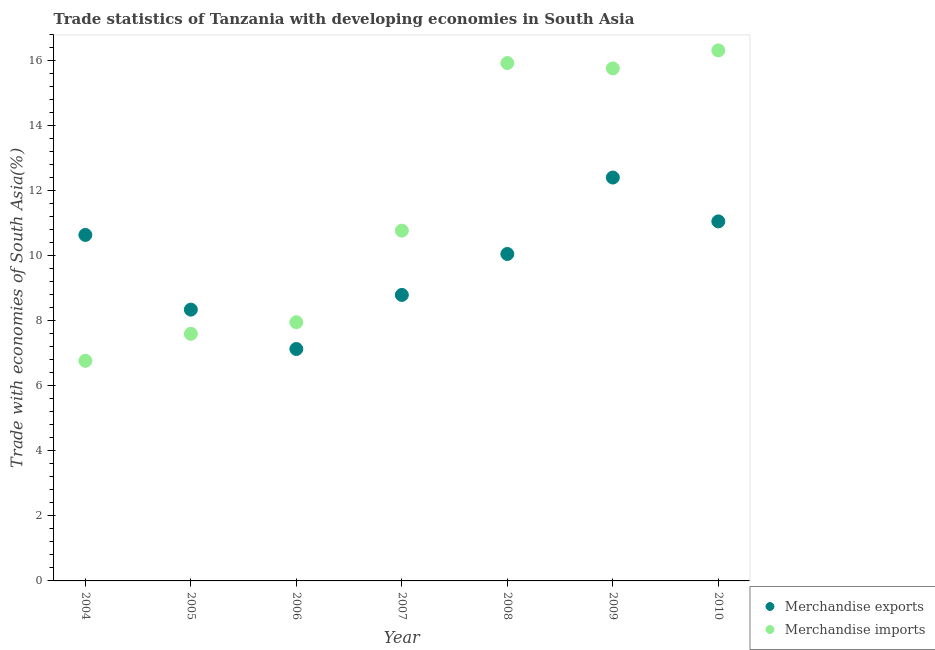What is the merchandise imports in 2004?
Ensure brevity in your answer.  6.77. Across all years, what is the maximum merchandise exports?
Offer a very short reply. 12.41. Across all years, what is the minimum merchandise imports?
Ensure brevity in your answer.  6.77. What is the total merchandise exports in the graph?
Give a very brief answer. 68.47. What is the difference between the merchandise imports in 2005 and that in 2006?
Give a very brief answer. -0.36. What is the difference between the merchandise imports in 2007 and the merchandise exports in 2009?
Your answer should be very brief. -1.63. What is the average merchandise exports per year?
Your answer should be very brief. 9.78. In the year 2008, what is the difference between the merchandise imports and merchandise exports?
Keep it short and to the point. 5.87. What is the ratio of the merchandise imports in 2004 to that in 2008?
Keep it short and to the point. 0.43. Is the merchandise exports in 2004 less than that in 2009?
Make the answer very short. Yes. What is the difference between the highest and the second highest merchandise imports?
Offer a terse response. 0.39. What is the difference between the highest and the lowest merchandise imports?
Offer a terse response. 9.55. In how many years, is the merchandise exports greater than the average merchandise exports taken over all years?
Your answer should be compact. 4. Does the merchandise exports monotonically increase over the years?
Your answer should be very brief. No. Is the merchandise exports strictly greater than the merchandise imports over the years?
Offer a terse response. No. Is the merchandise imports strictly less than the merchandise exports over the years?
Your answer should be compact. No. How many years are there in the graph?
Make the answer very short. 7. What is the difference between two consecutive major ticks on the Y-axis?
Provide a short and direct response. 2. Does the graph contain any zero values?
Your answer should be very brief. No. How many legend labels are there?
Make the answer very short. 2. How are the legend labels stacked?
Your answer should be very brief. Vertical. What is the title of the graph?
Ensure brevity in your answer.  Trade statistics of Tanzania with developing economies in South Asia. Does "ODA received" appear as one of the legend labels in the graph?
Your answer should be very brief. No. What is the label or title of the Y-axis?
Your answer should be very brief. Trade with economies of South Asia(%). What is the Trade with economies of South Asia(%) in Merchandise exports in 2004?
Offer a very short reply. 10.65. What is the Trade with economies of South Asia(%) of Merchandise imports in 2004?
Your answer should be compact. 6.77. What is the Trade with economies of South Asia(%) of Merchandise exports in 2005?
Give a very brief answer. 8.35. What is the Trade with economies of South Asia(%) of Merchandise imports in 2005?
Your answer should be very brief. 7.6. What is the Trade with economies of South Asia(%) in Merchandise exports in 2006?
Provide a short and direct response. 7.14. What is the Trade with economies of South Asia(%) in Merchandise imports in 2006?
Provide a short and direct response. 7.96. What is the Trade with economies of South Asia(%) of Merchandise exports in 2007?
Provide a short and direct response. 8.8. What is the Trade with economies of South Asia(%) of Merchandise imports in 2007?
Provide a short and direct response. 10.78. What is the Trade with economies of South Asia(%) in Merchandise exports in 2008?
Provide a succinct answer. 10.06. What is the Trade with economies of South Asia(%) of Merchandise imports in 2008?
Ensure brevity in your answer.  15.94. What is the Trade with economies of South Asia(%) in Merchandise exports in 2009?
Your response must be concise. 12.41. What is the Trade with economies of South Asia(%) of Merchandise imports in 2009?
Provide a short and direct response. 15.77. What is the Trade with economies of South Asia(%) of Merchandise exports in 2010?
Provide a succinct answer. 11.06. What is the Trade with economies of South Asia(%) of Merchandise imports in 2010?
Make the answer very short. 16.32. Across all years, what is the maximum Trade with economies of South Asia(%) of Merchandise exports?
Make the answer very short. 12.41. Across all years, what is the maximum Trade with economies of South Asia(%) in Merchandise imports?
Your answer should be compact. 16.32. Across all years, what is the minimum Trade with economies of South Asia(%) of Merchandise exports?
Your response must be concise. 7.14. Across all years, what is the minimum Trade with economies of South Asia(%) in Merchandise imports?
Provide a succinct answer. 6.77. What is the total Trade with economies of South Asia(%) in Merchandise exports in the graph?
Provide a succinct answer. 68.47. What is the total Trade with economies of South Asia(%) in Merchandise imports in the graph?
Ensure brevity in your answer.  81.15. What is the difference between the Trade with economies of South Asia(%) of Merchandise exports in 2004 and that in 2005?
Provide a succinct answer. 2.3. What is the difference between the Trade with economies of South Asia(%) of Merchandise imports in 2004 and that in 2005?
Offer a terse response. -0.83. What is the difference between the Trade with economies of South Asia(%) in Merchandise exports in 2004 and that in 2006?
Offer a very short reply. 3.51. What is the difference between the Trade with economies of South Asia(%) in Merchandise imports in 2004 and that in 2006?
Make the answer very short. -1.19. What is the difference between the Trade with economies of South Asia(%) of Merchandise exports in 2004 and that in 2007?
Keep it short and to the point. 1.85. What is the difference between the Trade with economies of South Asia(%) of Merchandise imports in 2004 and that in 2007?
Give a very brief answer. -4.01. What is the difference between the Trade with economies of South Asia(%) of Merchandise exports in 2004 and that in 2008?
Offer a terse response. 0.59. What is the difference between the Trade with economies of South Asia(%) of Merchandise imports in 2004 and that in 2008?
Offer a terse response. -9.16. What is the difference between the Trade with economies of South Asia(%) of Merchandise exports in 2004 and that in 2009?
Your response must be concise. -1.77. What is the difference between the Trade with economies of South Asia(%) in Merchandise imports in 2004 and that in 2009?
Make the answer very short. -9. What is the difference between the Trade with economies of South Asia(%) in Merchandise exports in 2004 and that in 2010?
Provide a short and direct response. -0.42. What is the difference between the Trade with economies of South Asia(%) in Merchandise imports in 2004 and that in 2010?
Offer a terse response. -9.55. What is the difference between the Trade with economies of South Asia(%) in Merchandise exports in 2005 and that in 2006?
Make the answer very short. 1.21. What is the difference between the Trade with economies of South Asia(%) of Merchandise imports in 2005 and that in 2006?
Your response must be concise. -0.36. What is the difference between the Trade with economies of South Asia(%) in Merchandise exports in 2005 and that in 2007?
Give a very brief answer. -0.45. What is the difference between the Trade with economies of South Asia(%) in Merchandise imports in 2005 and that in 2007?
Your answer should be very brief. -3.17. What is the difference between the Trade with economies of South Asia(%) in Merchandise exports in 2005 and that in 2008?
Provide a succinct answer. -1.71. What is the difference between the Trade with economies of South Asia(%) of Merchandise imports in 2005 and that in 2008?
Your answer should be very brief. -8.33. What is the difference between the Trade with economies of South Asia(%) of Merchandise exports in 2005 and that in 2009?
Provide a short and direct response. -4.06. What is the difference between the Trade with economies of South Asia(%) in Merchandise imports in 2005 and that in 2009?
Give a very brief answer. -8.17. What is the difference between the Trade with economies of South Asia(%) in Merchandise exports in 2005 and that in 2010?
Give a very brief answer. -2.71. What is the difference between the Trade with economies of South Asia(%) of Merchandise imports in 2005 and that in 2010?
Offer a very short reply. -8.72. What is the difference between the Trade with economies of South Asia(%) of Merchandise exports in 2006 and that in 2007?
Provide a short and direct response. -1.66. What is the difference between the Trade with economies of South Asia(%) of Merchandise imports in 2006 and that in 2007?
Offer a terse response. -2.82. What is the difference between the Trade with economies of South Asia(%) in Merchandise exports in 2006 and that in 2008?
Ensure brevity in your answer.  -2.92. What is the difference between the Trade with economies of South Asia(%) in Merchandise imports in 2006 and that in 2008?
Keep it short and to the point. -7.97. What is the difference between the Trade with economies of South Asia(%) of Merchandise exports in 2006 and that in 2009?
Provide a succinct answer. -5.28. What is the difference between the Trade with economies of South Asia(%) in Merchandise imports in 2006 and that in 2009?
Keep it short and to the point. -7.81. What is the difference between the Trade with economies of South Asia(%) of Merchandise exports in 2006 and that in 2010?
Your answer should be very brief. -3.93. What is the difference between the Trade with economies of South Asia(%) in Merchandise imports in 2006 and that in 2010?
Ensure brevity in your answer.  -8.36. What is the difference between the Trade with economies of South Asia(%) of Merchandise exports in 2007 and that in 2008?
Give a very brief answer. -1.26. What is the difference between the Trade with economies of South Asia(%) in Merchandise imports in 2007 and that in 2008?
Ensure brevity in your answer.  -5.16. What is the difference between the Trade with economies of South Asia(%) in Merchandise exports in 2007 and that in 2009?
Ensure brevity in your answer.  -3.61. What is the difference between the Trade with economies of South Asia(%) in Merchandise imports in 2007 and that in 2009?
Offer a very short reply. -4.99. What is the difference between the Trade with economies of South Asia(%) in Merchandise exports in 2007 and that in 2010?
Provide a short and direct response. -2.26. What is the difference between the Trade with economies of South Asia(%) of Merchandise imports in 2007 and that in 2010?
Ensure brevity in your answer.  -5.55. What is the difference between the Trade with economies of South Asia(%) of Merchandise exports in 2008 and that in 2009?
Offer a very short reply. -2.35. What is the difference between the Trade with economies of South Asia(%) of Merchandise imports in 2008 and that in 2009?
Provide a short and direct response. 0.17. What is the difference between the Trade with economies of South Asia(%) in Merchandise exports in 2008 and that in 2010?
Make the answer very short. -1. What is the difference between the Trade with economies of South Asia(%) of Merchandise imports in 2008 and that in 2010?
Offer a terse response. -0.39. What is the difference between the Trade with economies of South Asia(%) of Merchandise exports in 2009 and that in 2010?
Your response must be concise. 1.35. What is the difference between the Trade with economies of South Asia(%) of Merchandise imports in 2009 and that in 2010?
Ensure brevity in your answer.  -0.55. What is the difference between the Trade with economies of South Asia(%) of Merchandise exports in 2004 and the Trade with economies of South Asia(%) of Merchandise imports in 2005?
Offer a very short reply. 3.04. What is the difference between the Trade with economies of South Asia(%) in Merchandise exports in 2004 and the Trade with economies of South Asia(%) in Merchandise imports in 2006?
Provide a succinct answer. 2.69. What is the difference between the Trade with economies of South Asia(%) of Merchandise exports in 2004 and the Trade with economies of South Asia(%) of Merchandise imports in 2007?
Your answer should be very brief. -0.13. What is the difference between the Trade with economies of South Asia(%) of Merchandise exports in 2004 and the Trade with economies of South Asia(%) of Merchandise imports in 2008?
Your response must be concise. -5.29. What is the difference between the Trade with economies of South Asia(%) of Merchandise exports in 2004 and the Trade with economies of South Asia(%) of Merchandise imports in 2009?
Ensure brevity in your answer.  -5.12. What is the difference between the Trade with economies of South Asia(%) in Merchandise exports in 2004 and the Trade with economies of South Asia(%) in Merchandise imports in 2010?
Offer a terse response. -5.68. What is the difference between the Trade with economies of South Asia(%) in Merchandise exports in 2005 and the Trade with economies of South Asia(%) in Merchandise imports in 2006?
Your answer should be compact. 0.39. What is the difference between the Trade with economies of South Asia(%) of Merchandise exports in 2005 and the Trade with economies of South Asia(%) of Merchandise imports in 2007?
Your answer should be very brief. -2.43. What is the difference between the Trade with economies of South Asia(%) in Merchandise exports in 2005 and the Trade with economies of South Asia(%) in Merchandise imports in 2008?
Make the answer very short. -7.59. What is the difference between the Trade with economies of South Asia(%) of Merchandise exports in 2005 and the Trade with economies of South Asia(%) of Merchandise imports in 2009?
Make the answer very short. -7.42. What is the difference between the Trade with economies of South Asia(%) of Merchandise exports in 2005 and the Trade with economies of South Asia(%) of Merchandise imports in 2010?
Offer a very short reply. -7.98. What is the difference between the Trade with economies of South Asia(%) of Merchandise exports in 2006 and the Trade with economies of South Asia(%) of Merchandise imports in 2007?
Your answer should be very brief. -3.64. What is the difference between the Trade with economies of South Asia(%) in Merchandise exports in 2006 and the Trade with economies of South Asia(%) in Merchandise imports in 2008?
Provide a short and direct response. -8.8. What is the difference between the Trade with economies of South Asia(%) in Merchandise exports in 2006 and the Trade with economies of South Asia(%) in Merchandise imports in 2009?
Your response must be concise. -8.63. What is the difference between the Trade with economies of South Asia(%) of Merchandise exports in 2006 and the Trade with economies of South Asia(%) of Merchandise imports in 2010?
Provide a succinct answer. -9.19. What is the difference between the Trade with economies of South Asia(%) of Merchandise exports in 2007 and the Trade with economies of South Asia(%) of Merchandise imports in 2008?
Your answer should be very brief. -7.13. What is the difference between the Trade with economies of South Asia(%) of Merchandise exports in 2007 and the Trade with economies of South Asia(%) of Merchandise imports in 2009?
Make the answer very short. -6.97. What is the difference between the Trade with economies of South Asia(%) in Merchandise exports in 2007 and the Trade with economies of South Asia(%) in Merchandise imports in 2010?
Your answer should be very brief. -7.52. What is the difference between the Trade with economies of South Asia(%) of Merchandise exports in 2008 and the Trade with economies of South Asia(%) of Merchandise imports in 2009?
Ensure brevity in your answer.  -5.71. What is the difference between the Trade with economies of South Asia(%) of Merchandise exports in 2008 and the Trade with economies of South Asia(%) of Merchandise imports in 2010?
Keep it short and to the point. -6.26. What is the difference between the Trade with economies of South Asia(%) of Merchandise exports in 2009 and the Trade with economies of South Asia(%) of Merchandise imports in 2010?
Provide a succinct answer. -3.91. What is the average Trade with economies of South Asia(%) in Merchandise exports per year?
Offer a very short reply. 9.78. What is the average Trade with economies of South Asia(%) in Merchandise imports per year?
Give a very brief answer. 11.59. In the year 2004, what is the difference between the Trade with economies of South Asia(%) of Merchandise exports and Trade with economies of South Asia(%) of Merchandise imports?
Offer a very short reply. 3.87. In the year 2005, what is the difference between the Trade with economies of South Asia(%) of Merchandise exports and Trade with economies of South Asia(%) of Merchandise imports?
Your answer should be very brief. 0.74. In the year 2006, what is the difference between the Trade with economies of South Asia(%) in Merchandise exports and Trade with economies of South Asia(%) in Merchandise imports?
Offer a very short reply. -0.82. In the year 2007, what is the difference between the Trade with economies of South Asia(%) of Merchandise exports and Trade with economies of South Asia(%) of Merchandise imports?
Keep it short and to the point. -1.98. In the year 2008, what is the difference between the Trade with economies of South Asia(%) in Merchandise exports and Trade with economies of South Asia(%) in Merchandise imports?
Your answer should be compact. -5.87. In the year 2009, what is the difference between the Trade with economies of South Asia(%) of Merchandise exports and Trade with economies of South Asia(%) of Merchandise imports?
Your answer should be compact. -3.36. In the year 2010, what is the difference between the Trade with economies of South Asia(%) in Merchandise exports and Trade with economies of South Asia(%) in Merchandise imports?
Provide a short and direct response. -5.26. What is the ratio of the Trade with economies of South Asia(%) of Merchandise exports in 2004 to that in 2005?
Your answer should be compact. 1.28. What is the ratio of the Trade with economies of South Asia(%) of Merchandise imports in 2004 to that in 2005?
Provide a succinct answer. 0.89. What is the ratio of the Trade with economies of South Asia(%) in Merchandise exports in 2004 to that in 2006?
Give a very brief answer. 1.49. What is the ratio of the Trade with economies of South Asia(%) in Merchandise imports in 2004 to that in 2006?
Keep it short and to the point. 0.85. What is the ratio of the Trade with economies of South Asia(%) in Merchandise exports in 2004 to that in 2007?
Offer a terse response. 1.21. What is the ratio of the Trade with economies of South Asia(%) of Merchandise imports in 2004 to that in 2007?
Make the answer very short. 0.63. What is the ratio of the Trade with economies of South Asia(%) in Merchandise exports in 2004 to that in 2008?
Offer a very short reply. 1.06. What is the ratio of the Trade with economies of South Asia(%) in Merchandise imports in 2004 to that in 2008?
Keep it short and to the point. 0.42. What is the ratio of the Trade with economies of South Asia(%) in Merchandise exports in 2004 to that in 2009?
Your answer should be very brief. 0.86. What is the ratio of the Trade with economies of South Asia(%) of Merchandise imports in 2004 to that in 2009?
Your answer should be very brief. 0.43. What is the ratio of the Trade with economies of South Asia(%) of Merchandise exports in 2004 to that in 2010?
Provide a succinct answer. 0.96. What is the ratio of the Trade with economies of South Asia(%) of Merchandise imports in 2004 to that in 2010?
Make the answer very short. 0.41. What is the ratio of the Trade with economies of South Asia(%) in Merchandise exports in 2005 to that in 2006?
Offer a terse response. 1.17. What is the ratio of the Trade with economies of South Asia(%) in Merchandise imports in 2005 to that in 2006?
Provide a succinct answer. 0.96. What is the ratio of the Trade with economies of South Asia(%) in Merchandise exports in 2005 to that in 2007?
Make the answer very short. 0.95. What is the ratio of the Trade with economies of South Asia(%) of Merchandise imports in 2005 to that in 2007?
Offer a terse response. 0.71. What is the ratio of the Trade with economies of South Asia(%) of Merchandise exports in 2005 to that in 2008?
Provide a short and direct response. 0.83. What is the ratio of the Trade with economies of South Asia(%) in Merchandise imports in 2005 to that in 2008?
Offer a very short reply. 0.48. What is the ratio of the Trade with economies of South Asia(%) of Merchandise exports in 2005 to that in 2009?
Ensure brevity in your answer.  0.67. What is the ratio of the Trade with economies of South Asia(%) of Merchandise imports in 2005 to that in 2009?
Ensure brevity in your answer.  0.48. What is the ratio of the Trade with economies of South Asia(%) in Merchandise exports in 2005 to that in 2010?
Give a very brief answer. 0.75. What is the ratio of the Trade with economies of South Asia(%) of Merchandise imports in 2005 to that in 2010?
Provide a short and direct response. 0.47. What is the ratio of the Trade with economies of South Asia(%) of Merchandise exports in 2006 to that in 2007?
Your response must be concise. 0.81. What is the ratio of the Trade with economies of South Asia(%) of Merchandise imports in 2006 to that in 2007?
Ensure brevity in your answer.  0.74. What is the ratio of the Trade with economies of South Asia(%) in Merchandise exports in 2006 to that in 2008?
Make the answer very short. 0.71. What is the ratio of the Trade with economies of South Asia(%) in Merchandise imports in 2006 to that in 2008?
Your response must be concise. 0.5. What is the ratio of the Trade with economies of South Asia(%) of Merchandise exports in 2006 to that in 2009?
Offer a very short reply. 0.57. What is the ratio of the Trade with economies of South Asia(%) in Merchandise imports in 2006 to that in 2009?
Give a very brief answer. 0.5. What is the ratio of the Trade with economies of South Asia(%) in Merchandise exports in 2006 to that in 2010?
Give a very brief answer. 0.65. What is the ratio of the Trade with economies of South Asia(%) in Merchandise imports in 2006 to that in 2010?
Provide a succinct answer. 0.49. What is the ratio of the Trade with economies of South Asia(%) of Merchandise exports in 2007 to that in 2008?
Make the answer very short. 0.87. What is the ratio of the Trade with economies of South Asia(%) of Merchandise imports in 2007 to that in 2008?
Your answer should be compact. 0.68. What is the ratio of the Trade with economies of South Asia(%) of Merchandise exports in 2007 to that in 2009?
Make the answer very short. 0.71. What is the ratio of the Trade with economies of South Asia(%) in Merchandise imports in 2007 to that in 2009?
Provide a succinct answer. 0.68. What is the ratio of the Trade with economies of South Asia(%) of Merchandise exports in 2007 to that in 2010?
Provide a succinct answer. 0.8. What is the ratio of the Trade with economies of South Asia(%) of Merchandise imports in 2007 to that in 2010?
Offer a terse response. 0.66. What is the ratio of the Trade with economies of South Asia(%) in Merchandise exports in 2008 to that in 2009?
Your response must be concise. 0.81. What is the ratio of the Trade with economies of South Asia(%) of Merchandise imports in 2008 to that in 2009?
Provide a short and direct response. 1.01. What is the ratio of the Trade with economies of South Asia(%) in Merchandise exports in 2008 to that in 2010?
Offer a terse response. 0.91. What is the ratio of the Trade with economies of South Asia(%) of Merchandise imports in 2008 to that in 2010?
Make the answer very short. 0.98. What is the ratio of the Trade with economies of South Asia(%) of Merchandise exports in 2009 to that in 2010?
Keep it short and to the point. 1.12. What is the ratio of the Trade with economies of South Asia(%) of Merchandise imports in 2009 to that in 2010?
Make the answer very short. 0.97. What is the difference between the highest and the second highest Trade with economies of South Asia(%) of Merchandise exports?
Keep it short and to the point. 1.35. What is the difference between the highest and the second highest Trade with economies of South Asia(%) of Merchandise imports?
Make the answer very short. 0.39. What is the difference between the highest and the lowest Trade with economies of South Asia(%) in Merchandise exports?
Provide a succinct answer. 5.28. What is the difference between the highest and the lowest Trade with economies of South Asia(%) in Merchandise imports?
Ensure brevity in your answer.  9.55. 